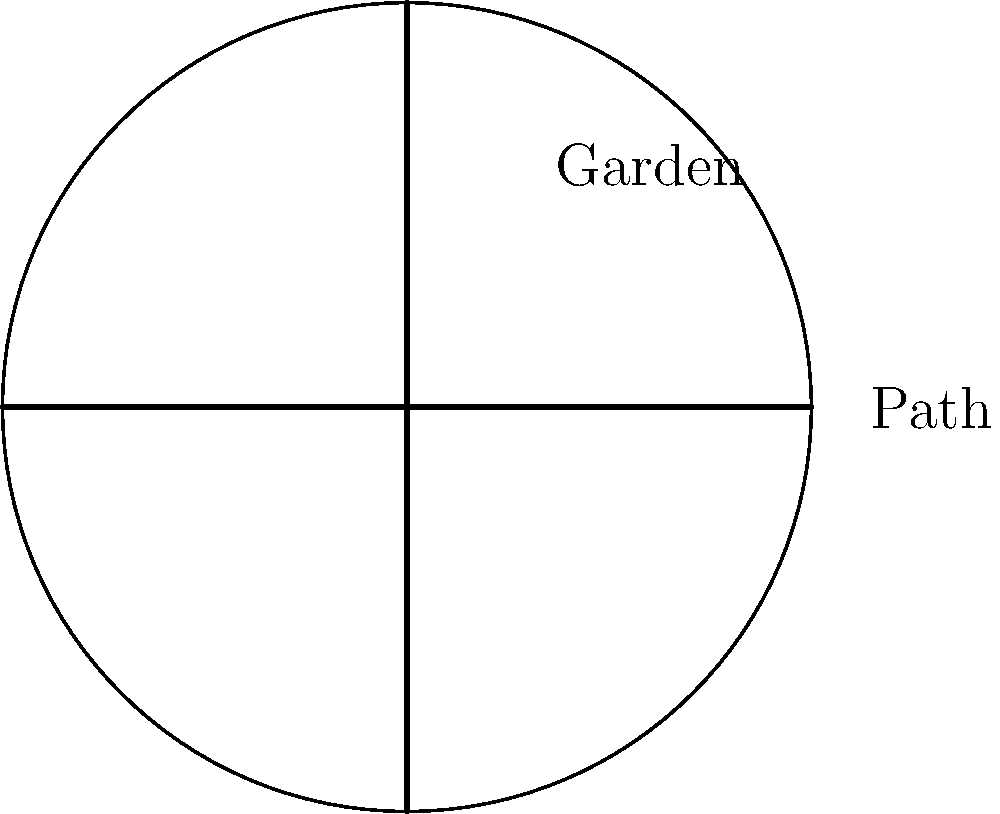In our church's circular garden, we've decided to create a cross-shaped path through its center, symbolizing our faith. The garden has a radius of 20 feet, and the path is 4 feet wide. What is the area of the garden that remains for planting, rounded to the nearest square foot? Consider this as an opportunity to reflect on how we can cultivate our spiritual understanding while tending to God's creation. Let's approach this step-by-step, remembering that all is Mind and its infinite manifestation:

1) First, calculate the total area of the circular garden:
   $$A_{total} = \pi r^2 = \pi (20^2) = 400\pi \approx 1256.64 \text{ sq ft}$$

2) Now, calculate the area of the cross-shaped path:
   - The path consists of two rectangles intersecting at the center
   - Each rectangle is 4 feet wide and 40 feet long (diameter of the garden)
   - The area of intersection is counted twice, so we need to subtract it once

3) Area of one rectangle of the path:
   $$A_{rectangle} = 4 \times 40 = 160 \text{ sq ft}$$

4) Area of both rectangles:
   $$A_{both} = 2 \times 160 = 320 \text{ sq ft}$$

5) Area of the intersection (the square at the center):
   $$A_{intersection} = 4 \times 4 = 16 \text{ sq ft}$$

6) Total area of the path:
   $$A_{path} = 320 - 16 = 304 \text{ sq ft}$$

7) Area remaining for planting:
   $$A_{planting} = A_{total} - A_{path} = 1256.64 - 304 = 952.64 \text{ sq ft}$$

8) Rounding to the nearest square foot:
   $$A_{planting} \approx 953 \text{ sq ft}$$

This calculation reminds us that even as we create structure in our spiritual lives, represented by the path, we still have ample space for growth and nurturing our faith.
Answer: 953 sq ft 